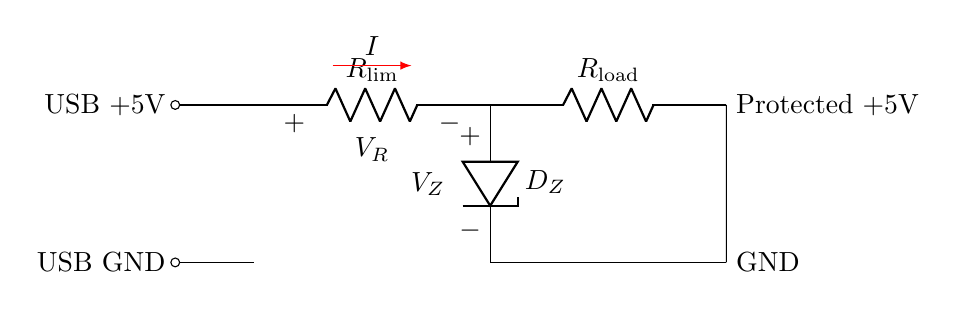What is the component labeled R_lim? The component labeled R_lim is a resistor that limits the current entering the load from the USB power supply. It is established in series to protect the downstream components.
Answer: Resistor What is the purpose of the Zener diode in this circuit? The Zener diode is used for overvoltage protection. It clamps the voltage to a safe level, preventing damage to the load in case of voltage spikes from the USB power supply.
Answer: Overvoltage protection What is the direction of current flow indicated by the arrow? The arrow shows that the current flows from the positive side of the circuit (USB +5V) through the limiting resistor and diode, then into the load. This indicates the conventional current flow in the circuit.
Answer: From USB to load What value does the schematic indicate the USB voltage to be? The schematic indicates that the USB voltage is 5 volts, which is standard for USB power. This is shown at the '+5V' label in the diagram.
Answer: 5 volts How is the load represented in the circuit? The load is represented in the circuit as a resistor, labeled R_load. This symbolizes any device that would draw power from the USB source.
Answer: Resistor What does the notation v equals V_R signify? The notation v equals V_R signifies the voltage across the limiting resistor. It shows that this resistor will develop a voltage drop proportional to the current flowing through it, affecting how much voltage is available to the load.
Answer: Voltage across R_lim 